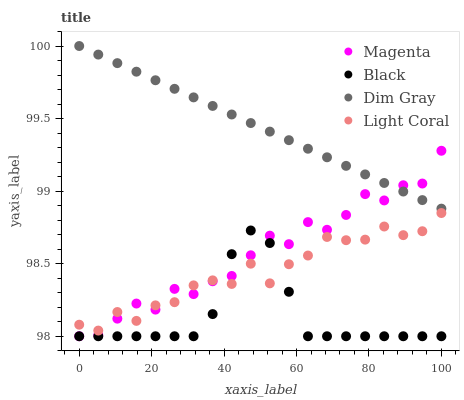Does Black have the minimum area under the curve?
Answer yes or no. Yes. Does Dim Gray have the maximum area under the curve?
Answer yes or no. Yes. Does Magenta have the minimum area under the curve?
Answer yes or no. No. Does Magenta have the maximum area under the curve?
Answer yes or no. No. Is Dim Gray the smoothest?
Answer yes or no. Yes. Is Magenta the roughest?
Answer yes or no. Yes. Is Magenta the smoothest?
Answer yes or no. No. Is Dim Gray the roughest?
Answer yes or no. No. Does Magenta have the lowest value?
Answer yes or no. Yes. Does Dim Gray have the lowest value?
Answer yes or no. No. Does Dim Gray have the highest value?
Answer yes or no. Yes. Does Magenta have the highest value?
Answer yes or no. No. Is Black less than Dim Gray?
Answer yes or no. Yes. Is Dim Gray greater than Black?
Answer yes or no. Yes. Does Black intersect Light Coral?
Answer yes or no. Yes. Is Black less than Light Coral?
Answer yes or no. No. Is Black greater than Light Coral?
Answer yes or no. No. Does Black intersect Dim Gray?
Answer yes or no. No. 